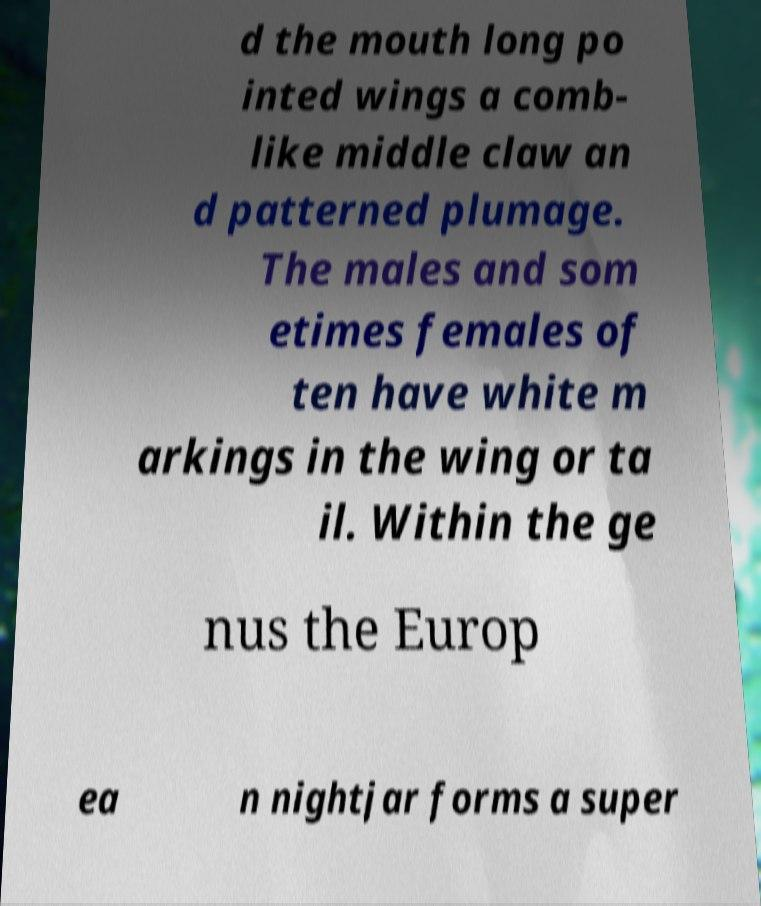Please read and relay the text visible in this image. What does it say? d the mouth long po inted wings a comb- like middle claw an d patterned plumage. The males and som etimes females of ten have white m arkings in the wing or ta il. Within the ge nus the Europ ea n nightjar forms a super 